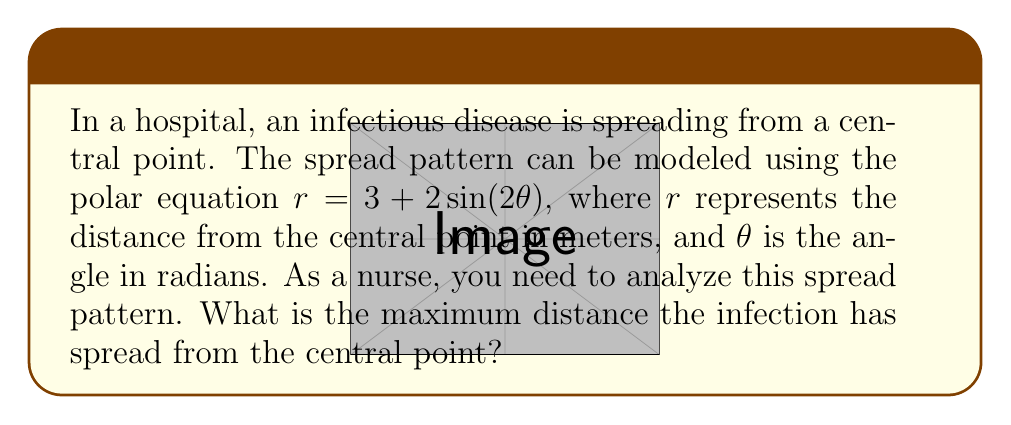Solve this math problem. To find the maximum distance the infection has spread, we need to determine the maximum value of $r$ in the given polar equation.

1) The equation is given as: $r = 3 + 2\sin(2\theta)$

2) The maximum value of $r$ will occur when $2\sin(2\theta)$ is at its maximum.

3) We know that the maximum value of sine function is 1, which occurs when its argument is $\frac{\pi}{2}$ or odd multiples of $\frac{\pi}{2}$.

4) So, we need to solve:
   $2\theta = \frac{\pi}{2}$ or odd multiples of $\frac{\pi}{2}$

5) The smallest positive value of $\theta$ that satisfies this is:
   $\theta = \frac{\pi}{4}$

6) At this value of $\theta$, $\sin(2\theta) = 1$

7) Substituting this back into our original equation:
   $r_{max} = 3 + 2(1) = 3 + 2 = 5$

Therefore, the maximum distance the infection has spread from the central point is 5 meters.

[asy]
import graph;
size(200);
real r(real t) {return 3+2*sin(2*t);}
draw(polargraph(r,0,2*pi),blue);
draw(circle((0,0),5),red+dashed);
dot((0,0));
label("Central point",(0,0),SW);
label("Max distance",(3.54,3.54),NE);
[/asy]
Answer: The maximum distance the infection has spread from the central point is 5 meters. 